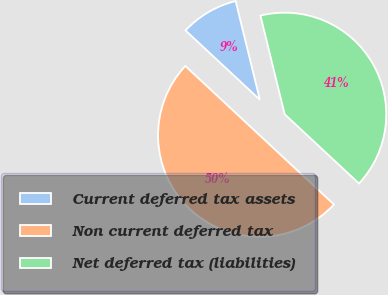Convert chart. <chart><loc_0><loc_0><loc_500><loc_500><pie_chart><fcel>Current deferred tax assets<fcel>Non current deferred tax<fcel>Net deferred tax (liabilities)<nl><fcel>9.23%<fcel>50.0%<fcel>40.77%<nl></chart> 